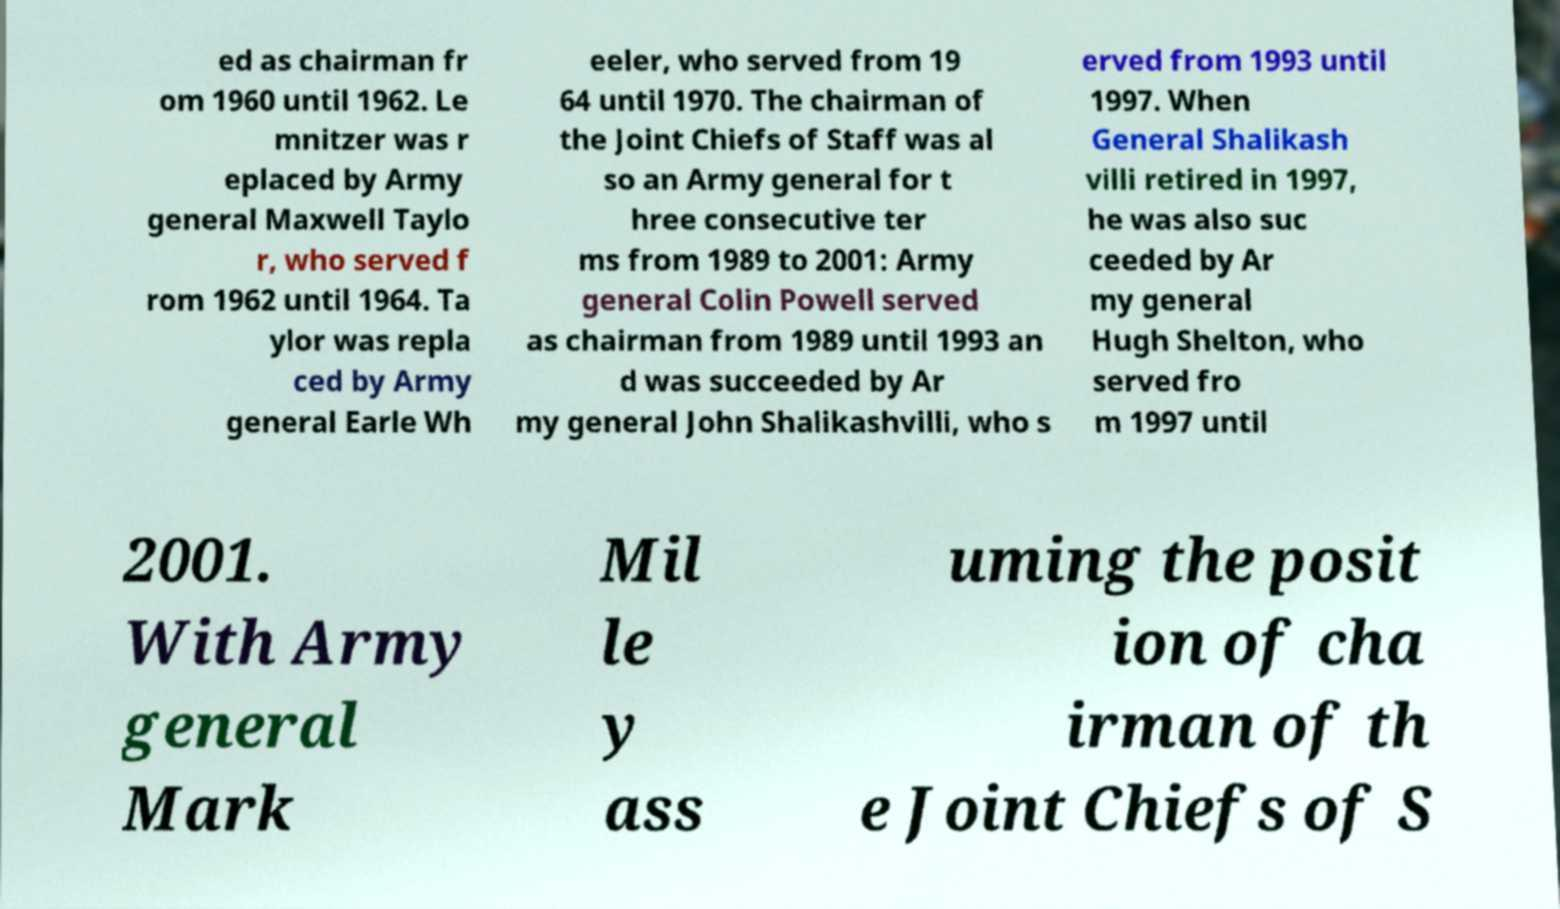Could you assist in decoding the text presented in this image and type it out clearly? ed as chairman fr om 1960 until 1962. Le mnitzer was r eplaced by Army general Maxwell Taylo r, who served f rom 1962 until 1964. Ta ylor was repla ced by Army general Earle Wh eeler, who served from 19 64 until 1970. The chairman of the Joint Chiefs of Staff was al so an Army general for t hree consecutive ter ms from 1989 to 2001: Army general Colin Powell served as chairman from 1989 until 1993 an d was succeeded by Ar my general John Shalikashvilli, who s erved from 1993 until 1997. When General Shalikash villi retired in 1997, he was also suc ceeded by Ar my general Hugh Shelton, who served fro m 1997 until 2001. With Army general Mark Mil le y ass uming the posit ion of cha irman of th e Joint Chiefs of S 